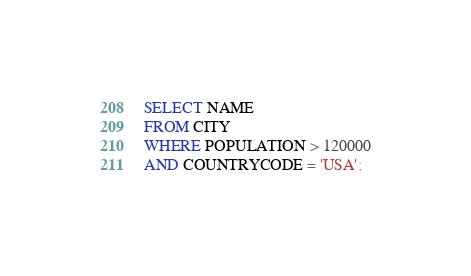<code> <loc_0><loc_0><loc_500><loc_500><_SQL_>SELECT NAME
FROM CITY
WHERE POPULATION > 120000
AND COUNTRYCODE = 'USA';</code> 